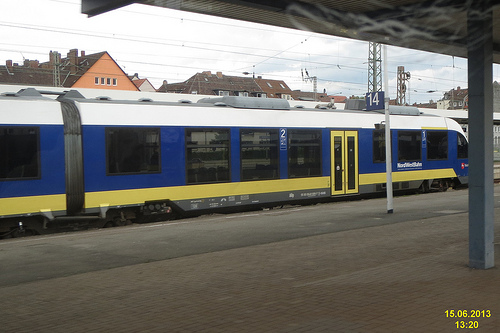Is this place a train station or an airport? This location is a train station, evident from the train on its tracks and the typical station layout visible. 